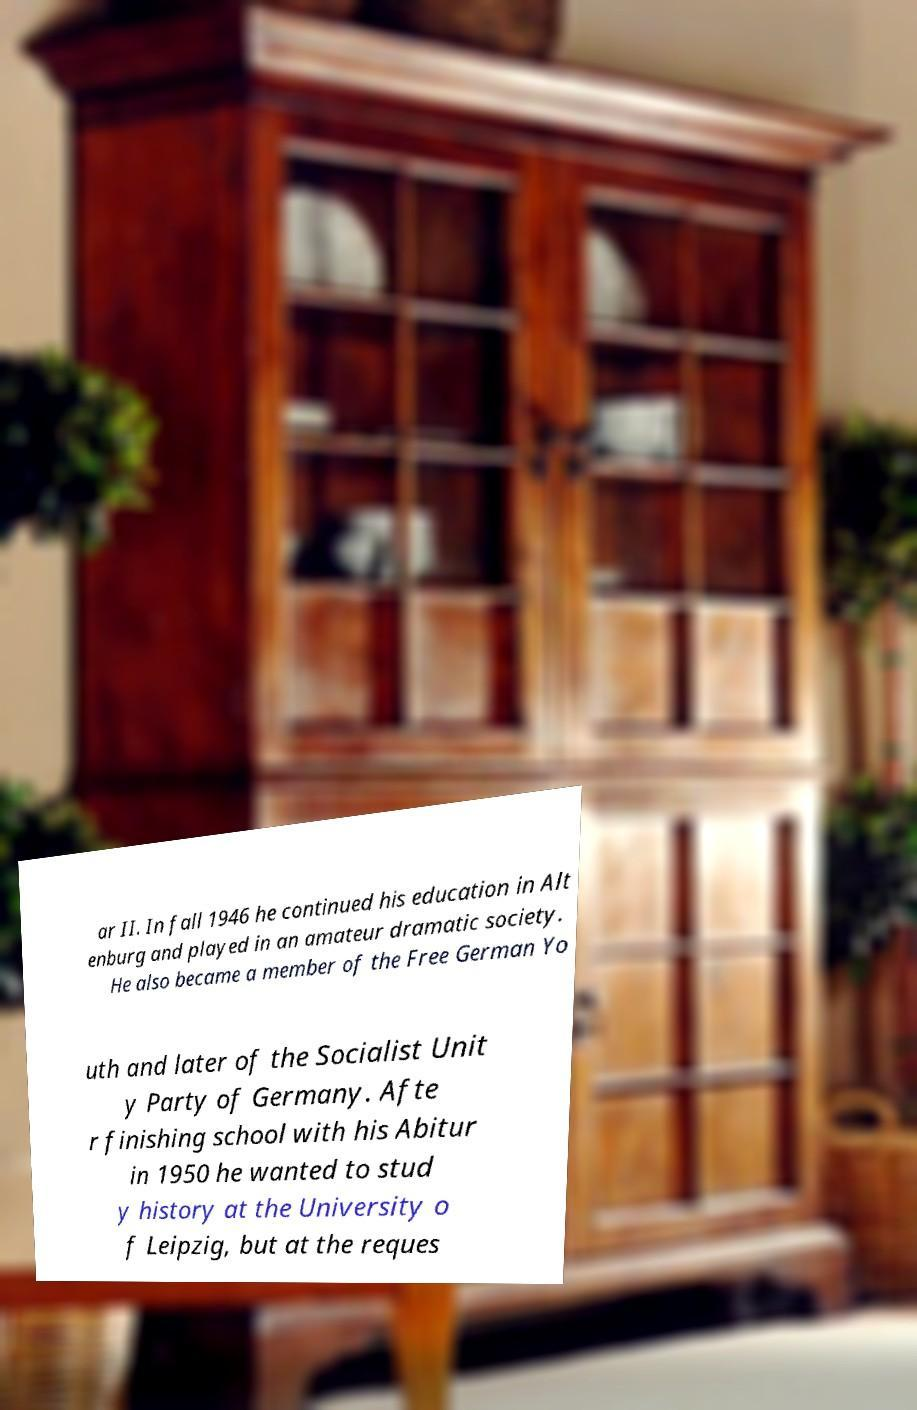What messages or text are displayed in this image? I need them in a readable, typed format. ar II. In fall 1946 he continued his education in Alt enburg and played in an amateur dramatic society. He also became a member of the Free German Yo uth and later of the Socialist Unit y Party of Germany. Afte r finishing school with his Abitur in 1950 he wanted to stud y history at the University o f Leipzig, but at the reques 